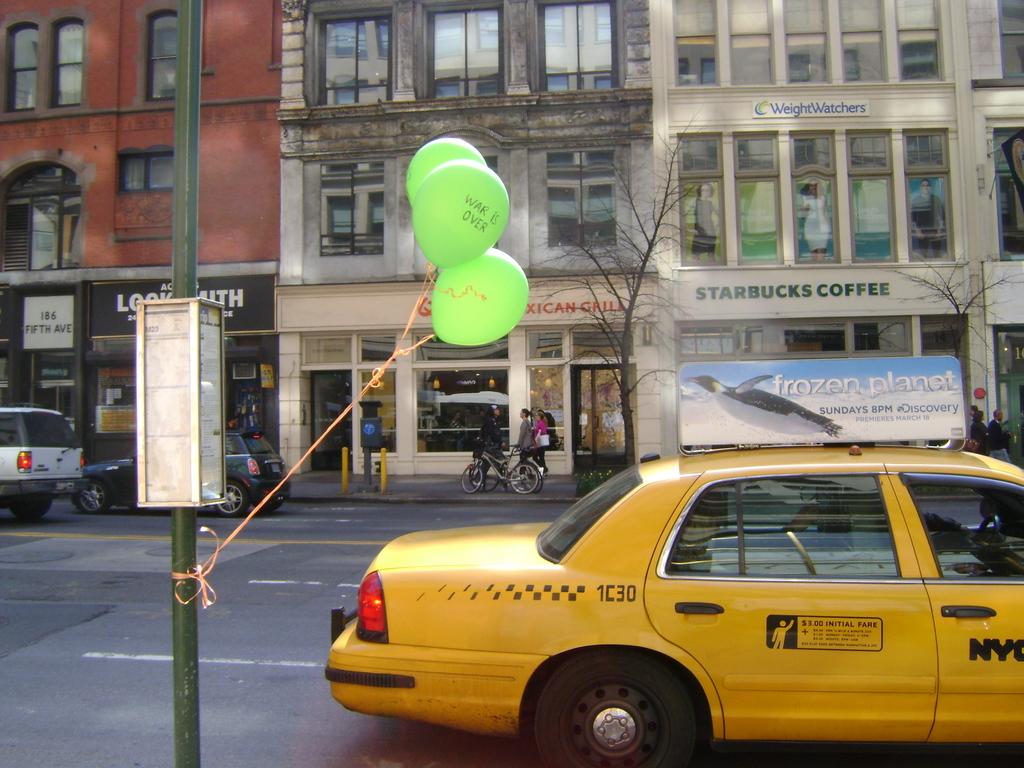What ad is on top of the cab?
Provide a short and direct response. Frozen planet. Is there a starbucks nearby?
Your response must be concise. Yes. 